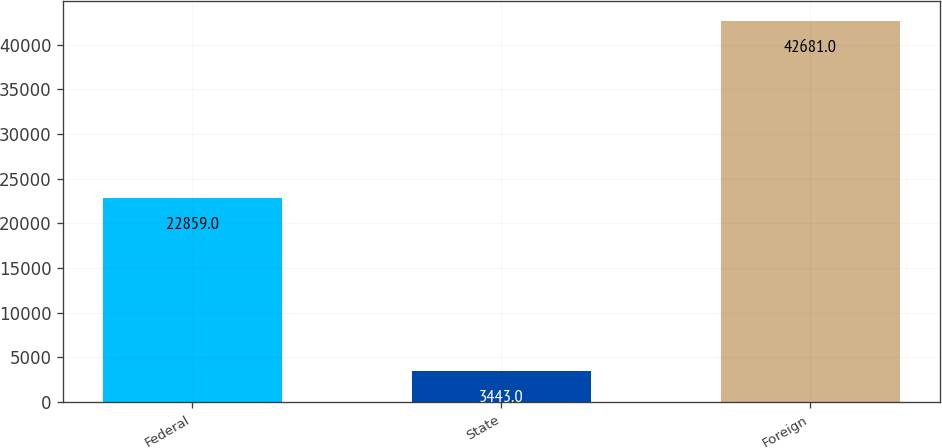Convert chart to OTSL. <chart><loc_0><loc_0><loc_500><loc_500><bar_chart><fcel>Federal<fcel>State<fcel>Foreign<nl><fcel>22859<fcel>3443<fcel>42681<nl></chart> 